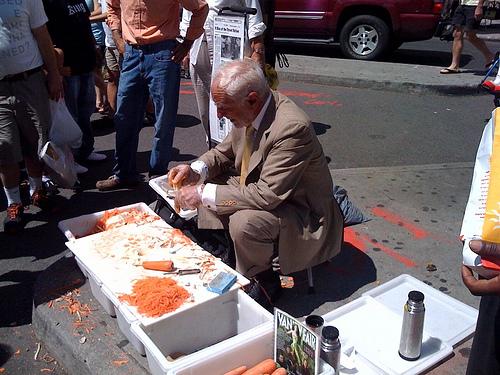Is the man cooking or doing a demonstration?
Be succinct. Demonstration. Is he wearing khaki shorts?
Concise answer only. No. Why does the man have a bag?
Write a very short answer. Carrying. Is the man wearing a hat?
Be succinct. No. What color is the spray paint?
Give a very brief answer. Red. Where is the knife?
Give a very brief answer. Cutting board. What vegetable is being cooked?
Answer briefly. Carrots. Does the weather appear to be cold?
Concise answer only. No. 